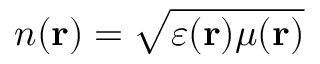<formula> <loc_0><loc_0><loc_500><loc_500>n ( r ) = \sqrt { \varepsilon ( r ) \mu ( r ) }</formula> 